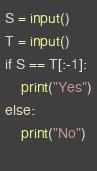Convert code to text. <code><loc_0><loc_0><loc_500><loc_500><_Python_>S = input()
T = input()
if S == T[:-1]:
    print("Yes")
else:
    print("No")
    </code> 